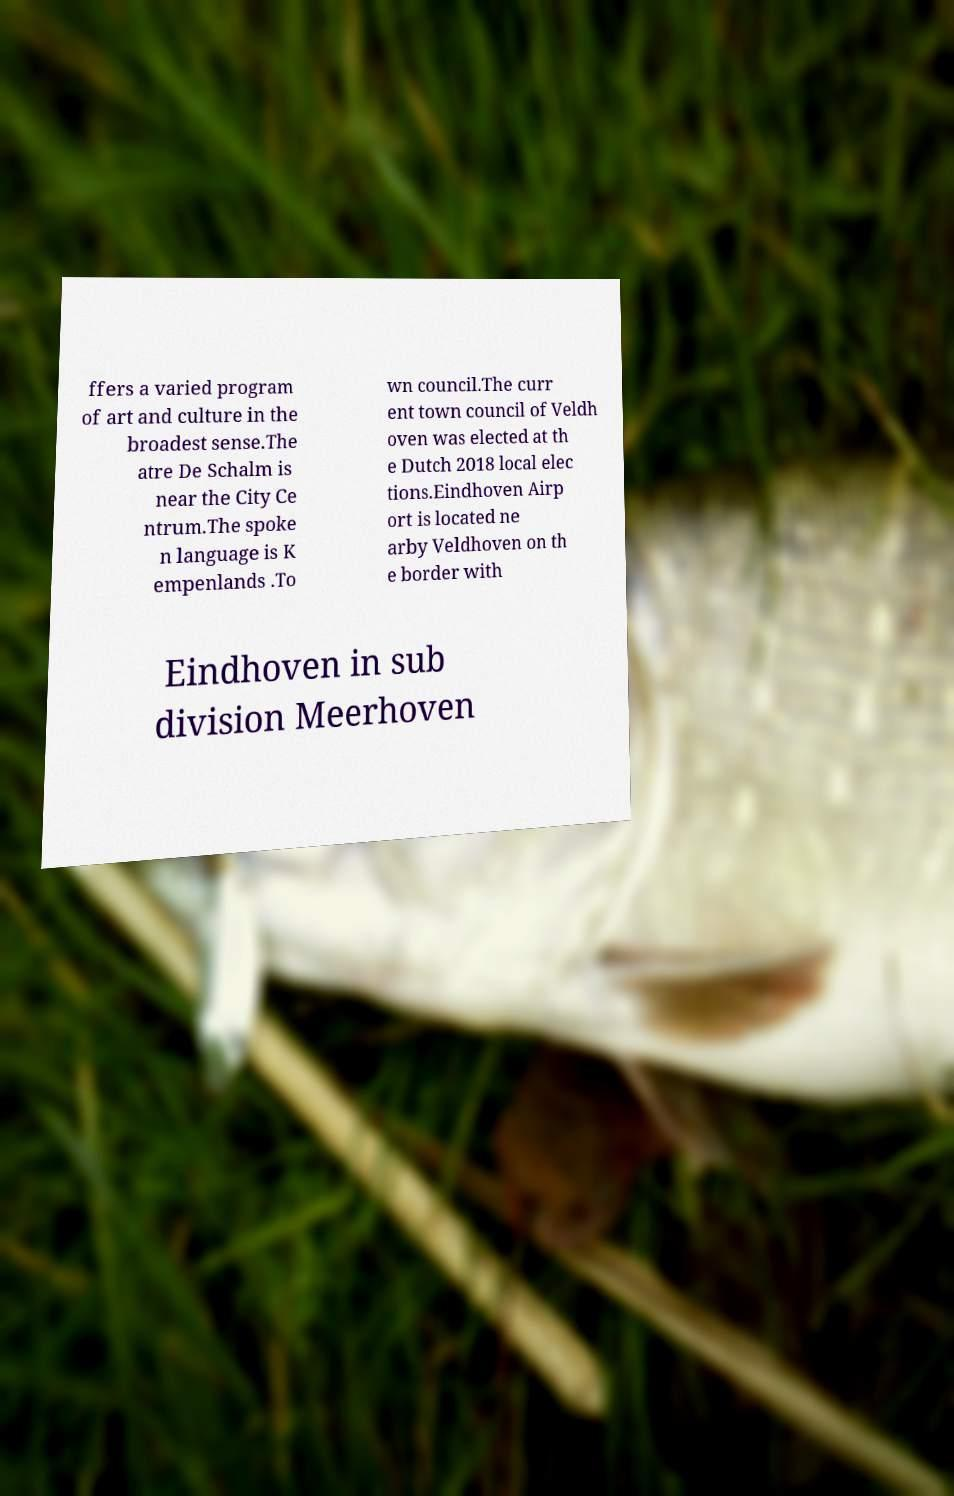What messages or text are displayed in this image? I need them in a readable, typed format. ffers a varied program of art and culture in the broadest sense.The atre De Schalm is near the City Ce ntrum.The spoke n language is K empenlands .To wn council.The curr ent town council of Veldh oven was elected at th e Dutch 2018 local elec tions.Eindhoven Airp ort is located ne arby Veldhoven on th e border with Eindhoven in sub division Meerhoven 